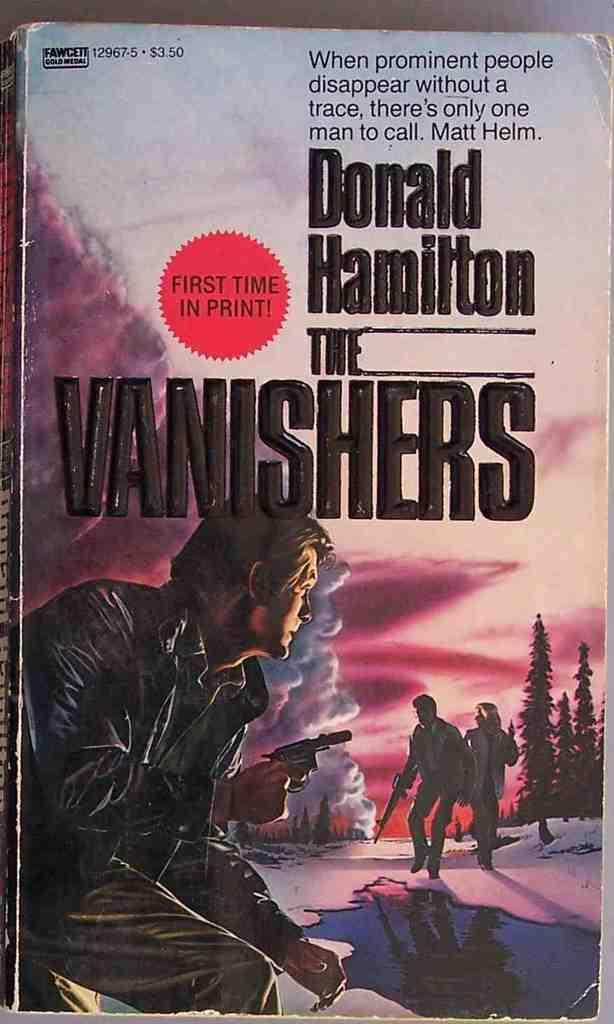Provide a one-sentence caption for the provided image. The book The Vanishers written by Donald Hamilton. 